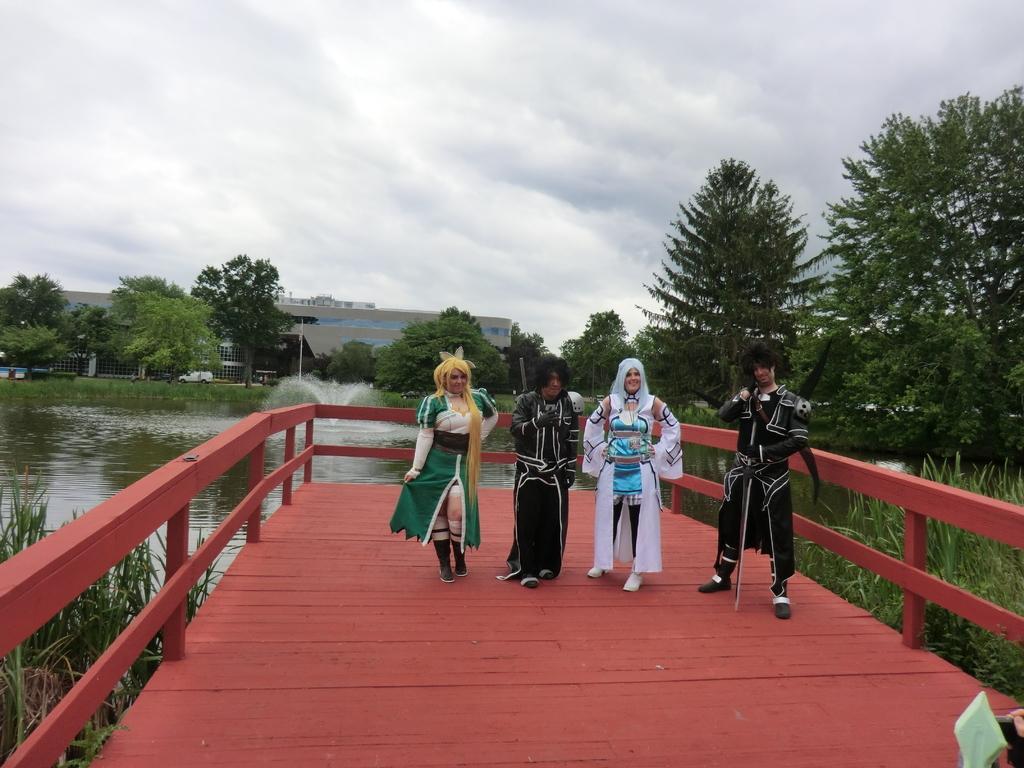How would you summarize this image in a sentence or two? In this image we can see a group of people standing on the bridge. We can also see a fence, plants, the fountain, water, a truck, a group of trees, a building and the sky which looks cloudy. 